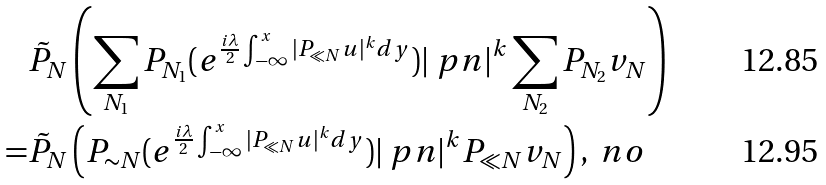<formula> <loc_0><loc_0><loc_500><loc_500>& \tilde { P } _ { N } \left ( \sum _ { N _ { 1 } } P _ { N _ { 1 } } ( e ^ { \frac { i \lambda } { 2 } \int _ { - \infty } ^ { x } | P _ { \ll N } u | ^ { k } d y } ) | \ p n | ^ { k } \sum _ { N _ { 2 } } P _ { N _ { 2 } } v _ { N } \right ) \\ = & \tilde { P } _ { N } \left ( P _ { \sim N } ( e ^ { \frac { i \lambda } { 2 } \int _ { - \infty } ^ { x } | P _ { \ll N } u | ^ { k } d y } ) | \ p n | ^ { k } P _ { \ll N } v _ { N } \right ) , \ n o</formula> 